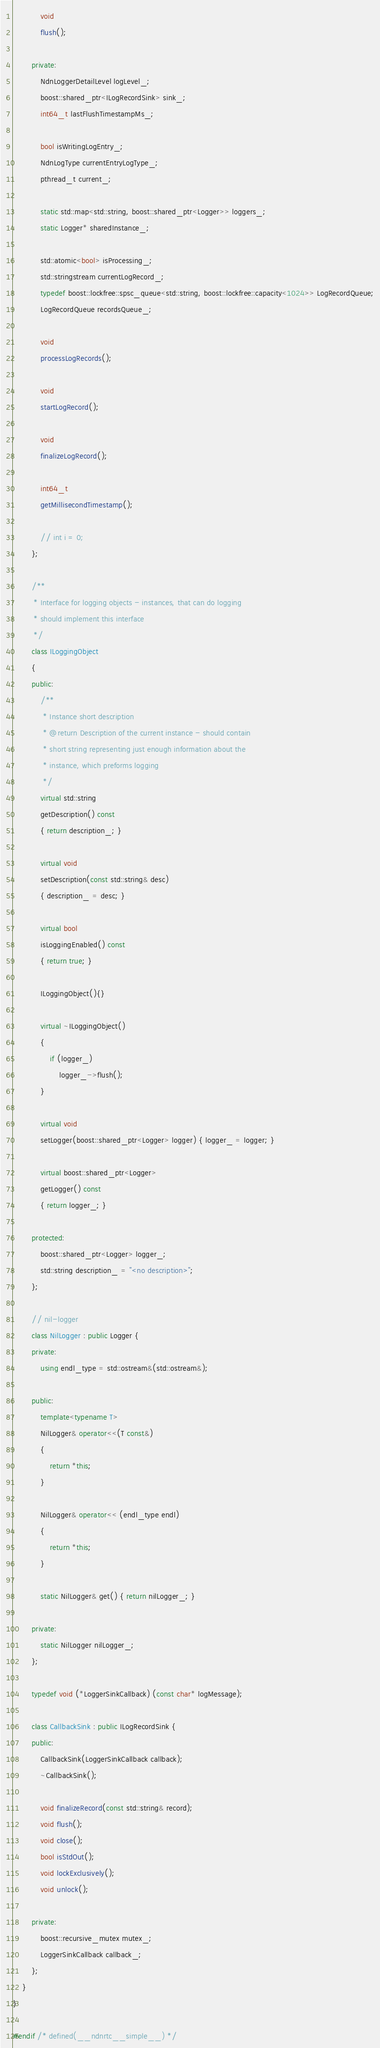Convert code to text. <code><loc_0><loc_0><loc_500><loc_500><_C++_>            void
            flush();
            
        private:
            NdnLoggerDetailLevel logLevel_;
            boost::shared_ptr<ILogRecordSink> sink_;
            int64_t lastFlushTimestampMs_;
            
            bool isWritingLogEntry_;
            NdnLogType currentEntryLogType_;
            pthread_t current_;
            
            static std::map<std::string, boost::shared_ptr<Logger>> loggers_;
            static Logger* sharedInstance_;
            
            std::atomic<bool> isProcessing_;
            std::stringstream currentLogRecord_;
            typedef boost::lockfree::spsc_queue<std::string, boost::lockfree::capacity<1024>> LogRecordQueue;
            LogRecordQueue recordsQueue_;
            
            void
            processLogRecords();
            
            void
            startLogRecord();
            
            void
            finalizeLogRecord();
            
            int64_t
            getMillisecondTimestamp();
            
            // int i = 0;
        };
        
        /**
         * Interface for logging objects - instances, that can do logging 
         * should implement this interface
         */
        class ILoggingObject
        {
        public:
            /**
             * Instance short description
             * @return Description of the current instance - should contain 
             * short string representing just enough information about the 
             * instance, which preforms logging
             */
            virtual std::string
            getDescription() const
            { return description_; }
            
            virtual void
            setDescription(const std::string& desc)
            { description_ = desc; }
            
            virtual bool
            isLoggingEnabled() const
            { return true; }
            
            ILoggingObject(){}
            
            virtual ~ILoggingObject()
            {
                if (logger_)
                    logger_->flush();
            }
            
            virtual void
            setLogger(boost::shared_ptr<Logger> logger) { logger_ = logger; }
            
            virtual boost::shared_ptr<Logger>
            getLogger() const
            { return logger_; }
            
        protected:
            boost::shared_ptr<Logger> logger_;
            std::string description_ = "<no description>";
        };
        
        // nil-logger
        class NilLogger : public Logger {
        private:
            using endl_type = std::ostream&(std::ostream&);
            
        public:
            template<typename T>
            NilLogger& operator<<(T const&)
            { 
                return *this;
            }
            
            NilLogger& operator<< (endl_type endl)
            {
                return *this;
            }
            
            static NilLogger& get() { return nilLogger_; }
            
        private:
            static NilLogger nilLogger_;
        };

        typedef void (*LoggerSinkCallback) (const char* logMessage);

        class CallbackSink : public ILogRecordSink {
        public:
            CallbackSink(LoggerSinkCallback callback);
            ~CallbackSink();

            void finalizeRecord(const std::string& record);
            void flush();
            void close();
            bool isStdOut();
            void lockExclusively();
            void unlock();

        private:
            boost::recursive_mutex mutex_;
            LoggerSinkCallback callback_;
        };
    }
}

#endif /* defined(__ndnrtc__simple__) */
</code> 